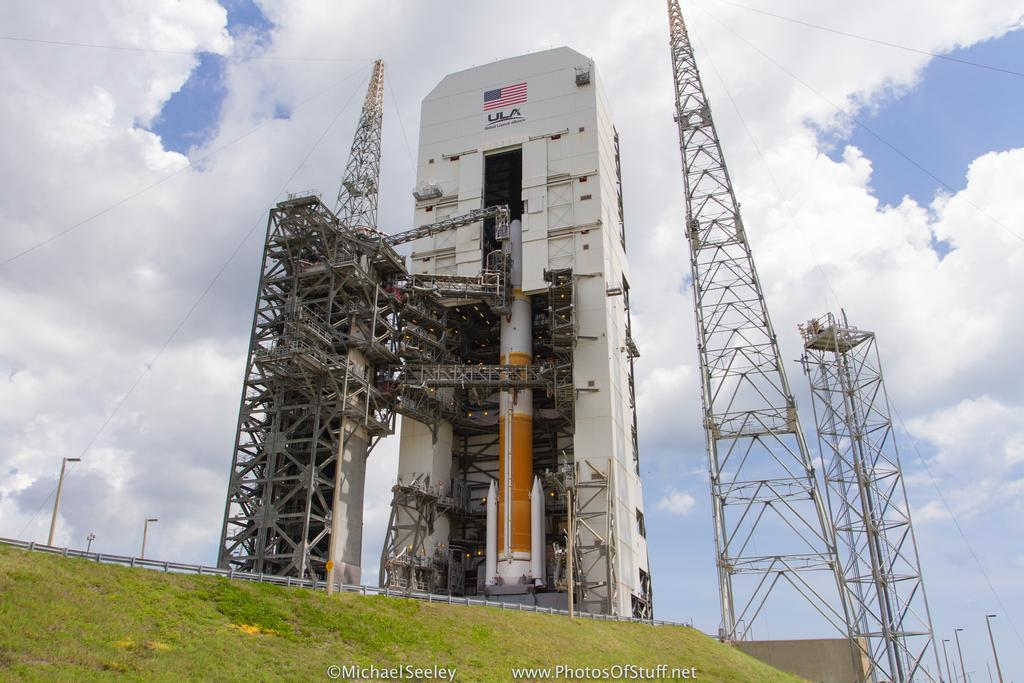Provide a one-sentence caption for the provided image. Under the American Flag it says United Launch Alliance. 